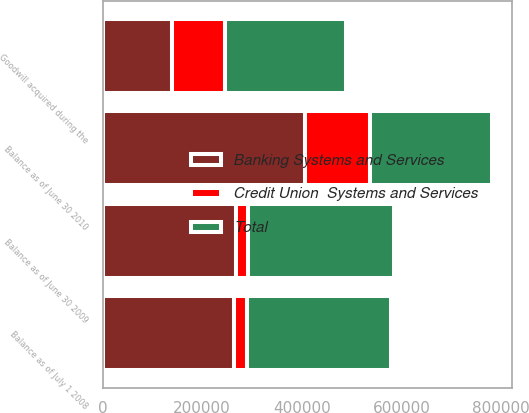<chart> <loc_0><loc_0><loc_500><loc_500><stacked_bar_chart><ecel><fcel>Balance as of July 1 2008<fcel>Balance as of June 30 2009<fcel>Goodwill acquired during the<fcel>Balance as of June 30 2010<nl><fcel>Banking Systems and Services<fcel>264575<fcel>267602<fcel>138319<fcel>405921<nl><fcel>Credit Union  Systems and Services<fcel>24798<fcel>24798<fcel>106387<fcel>131185<nl><fcel>Total<fcel>289373<fcel>292400<fcel>244706<fcel>244706<nl></chart> 